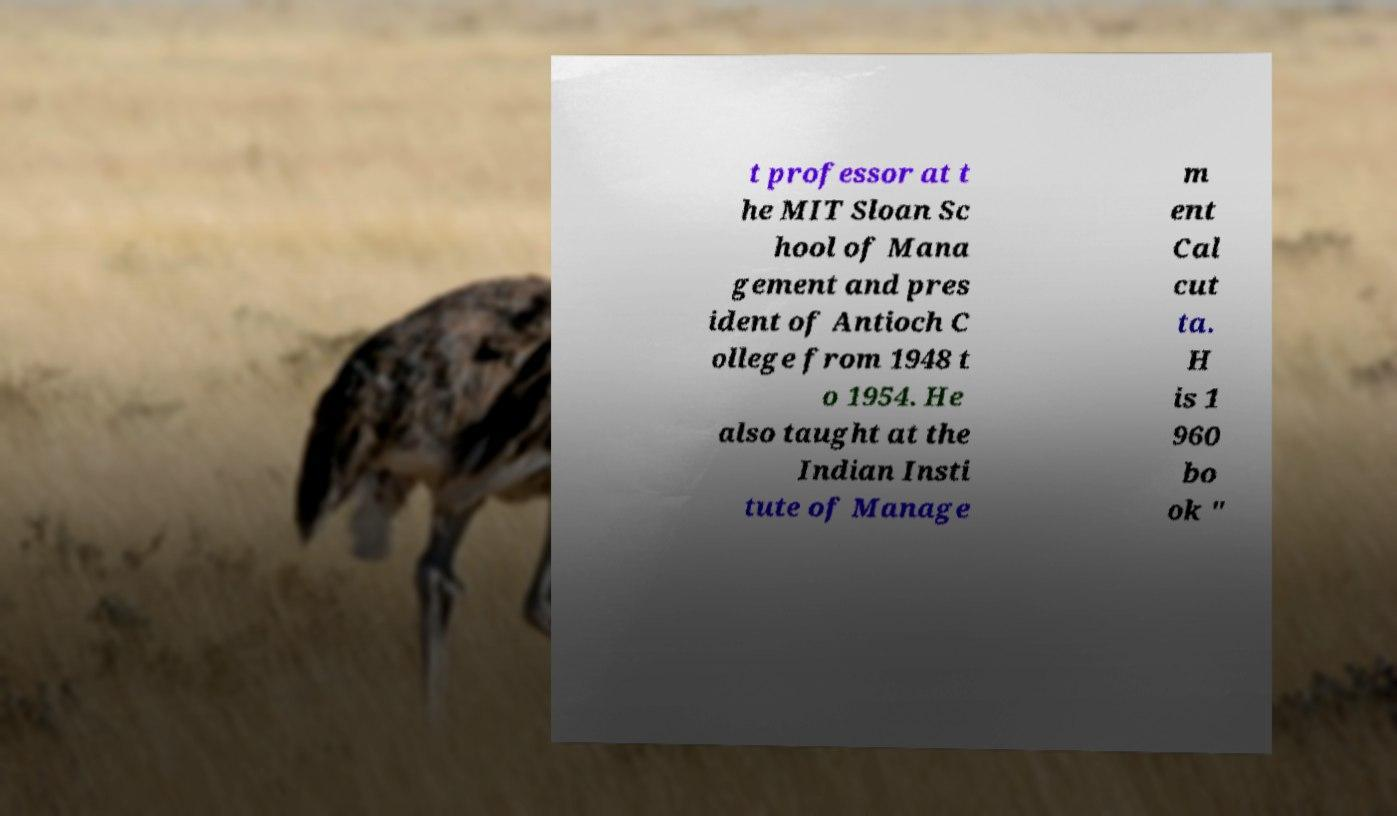For documentation purposes, I need the text within this image transcribed. Could you provide that? t professor at t he MIT Sloan Sc hool of Mana gement and pres ident of Antioch C ollege from 1948 t o 1954. He also taught at the Indian Insti tute of Manage m ent Cal cut ta. H is 1 960 bo ok " 